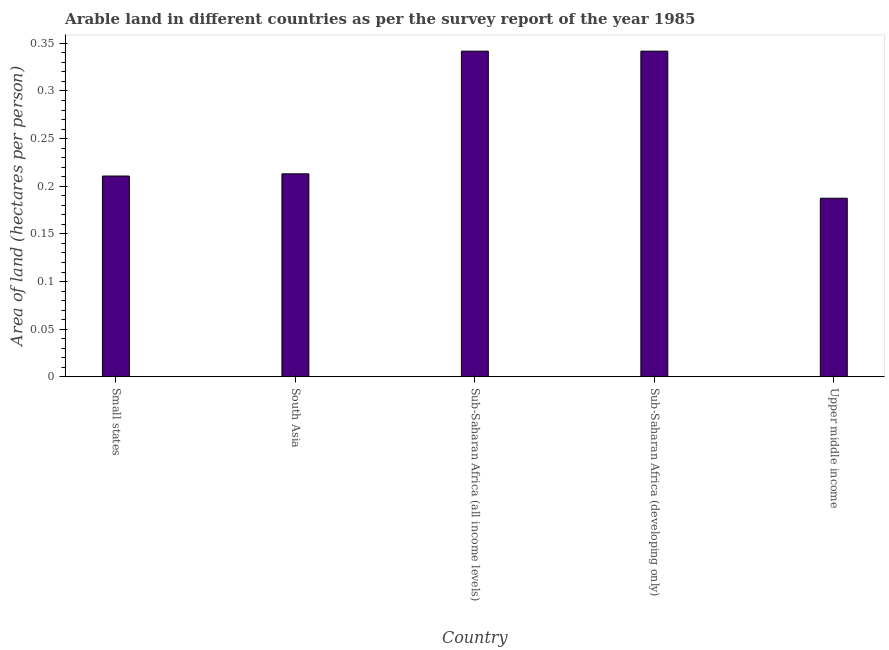Does the graph contain any zero values?
Provide a succinct answer. No. What is the title of the graph?
Ensure brevity in your answer.  Arable land in different countries as per the survey report of the year 1985. What is the label or title of the Y-axis?
Your response must be concise. Area of land (hectares per person). What is the area of arable land in Upper middle income?
Your response must be concise. 0.19. Across all countries, what is the maximum area of arable land?
Offer a terse response. 0.34. Across all countries, what is the minimum area of arable land?
Give a very brief answer. 0.19. In which country was the area of arable land maximum?
Give a very brief answer. Sub-Saharan Africa (all income levels). In which country was the area of arable land minimum?
Ensure brevity in your answer.  Upper middle income. What is the sum of the area of arable land?
Your answer should be compact. 1.29. What is the difference between the area of arable land in South Asia and Sub-Saharan Africa (developing only)?
Offer a terse response. -0.13. What is the average area of arable land per country?
Provide a succinct answer. 0.26. What is the median area of arable land?
Offer a very short reply. 0.21. What is the ratio of the area of arable land in Small states to that in Upper middle income?
Provide a short and direct response. 1.12. What is the difference between the highest and the second highest area of arable land?
Make the answer very short. 0. What is the difference between the highest and the lowest area of arable land?
Your response must be concise. 0.15. How many bars are there?
Provide a short and direct response. 5. How many countries are there in the graph?
Your answer should be very brief. 5. Are the values on the major ticks of Y-axis written in scientific E-notation?
Your answer should be compact. No. What is the Area of land (hectares per person) of Small states?
Your answer should be very brief. 0.21. What is the Area of land (hectares per person) of South Asia?
Your response must be concise. 0.21. What is the Area of land (hectares per person) of Sub-Saharan Africa (all income levels)?
Keep it short and to the point. 0.34. What is the Area of land (hectares per person) in Sub-Saharan Africa (developing only)?
Offer a very short reply. 0.34. What is the Area of land (hectares per person) of Upper middle income?
Provide a succinct answer. 0.19. What is the difference between the Area of land (hectares per person) in Small states and South Asia?
Your answer should be compact. -0. What is the difference between the Area of land (hectares per person) in Small states and Sub-Saharan Africa (all income levels)?
Make the answer very short. -0.13. What is the difference between the Area of land (hectares per person) in Small states and Sub-Saharan Africa (developing only)?
Your response must be concise. -0.13. What is the difference between the Area of land (hectares per person) in Small states and Upper middle income?
Make the answer very short. 0.02. What is the difference between the Area of land (hectares per person) in South Asia and Sub-Saharan Africa (all income levels)?
Give a very brief answer. -0.13. What is the difference between the Area of land (hectares per person) in South Asia and Sub-Saharan Africa (developing only)?
Offer a very short reply. -0.13. What is the difference between the Area of land (hectares per person) in South Asia and Upper middle income?
Provide a short and direct response. 0.03. What is the difference between the Area of land (hectares per person) in Sub-Saharan Africa (all income levels) and Upper middle income?
Offer a very short reply. 0.15. What is the difference between the Area of land (hectares per person) in Sub-Saharan Africa (developing only) and Upper middle income?
Your response must be concise. 0.15. What is the ratio of the Area of land (hectares per person) in Small states to that in South Asia?
Your response must be concise. 0.99. What is the ratio of the Area of land (hectares per person) in Small states to that in Sub-Saharan Africa (all income levels)?
Keep it short and to the point. 0.62. What is the ratio of the Area of land (hectares per person) in Small states to that in Sub-Saharan Africa (developing only)?
Provide a succinct answer. 0.62. What is the ratio of the Area of land (hectares per person) in Small states to that in Upper middle income?
Give a very brief answer. 1.12. What is the ratio of the Area of land (hectares per person) in South Asia to that in Sub-Saharan Africa (all income levels)?
Your answer should be compact. 0.62. What is the ratio of the Area of land (hectares per person) in South Asia to that in Sub-Saharan Africa (developing only)?
Make the answer very short. 0.62. What is the ratio of the Area of land (hectares per person) in South Asia to that in Upper middle income?
Give a very brief answer. 1.14. What is the ratio of the Area of land (hectares per person) in Sub-Saharan Africa (all income levels) to that in Sub-Saharan Africa (developing only)?
Provide a short and direct response. 1. What is the ratio of the Area of land (hectares per person) in Sub-Saharan Africa (all income levels) to that in Upper middle income?
Your answer should be very brief. 1.82. What is the ratio of the Area of land (hectares per person) in Sub-Saharan Africa (developing only) to that in Upper middle income?
Make the answer very short. 1.82. 